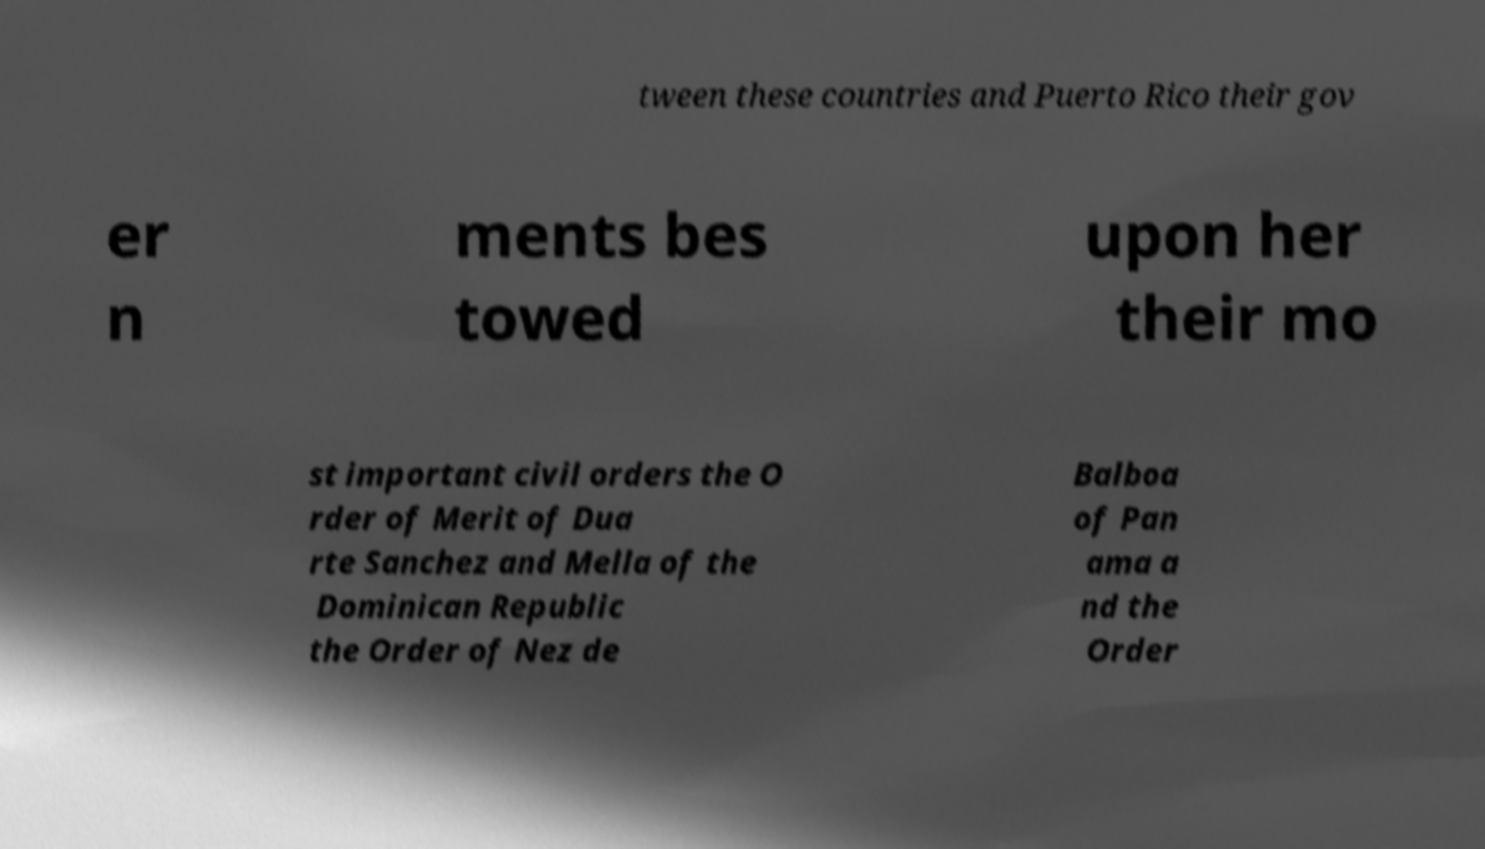Could you extract and type out the text from this image? tween these countries and Puerto Rico their gov er n ments bes towed upon her their mo st important civil orders the O rder of Merit of Dua rte Sanchez and Mella of the Dominican Republic the Order of Nez de Balboa of Pan ama a nd the Order 